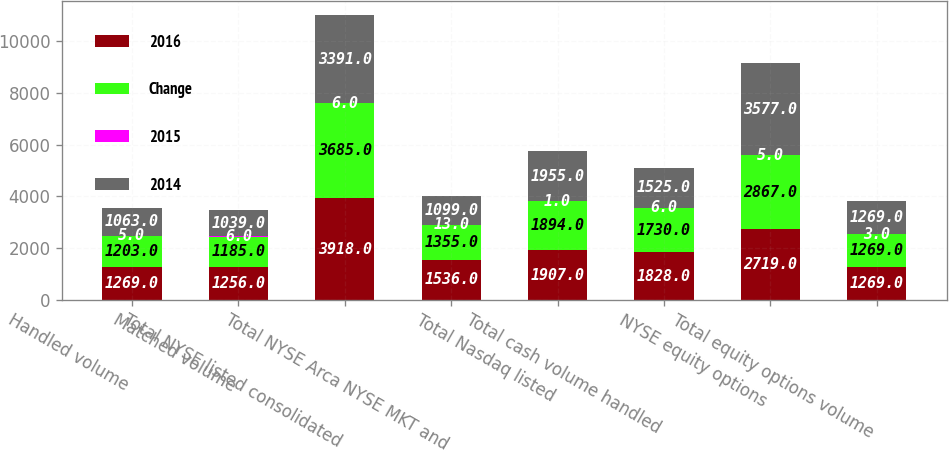<chart> <loc_0><loc_0><loc_500><loc_500><stacked_bar_chart><ecel><fcel>Handled volume<fcel>Matched volume<fcel>Total NYSE listed consolidated<fcel>Total NYSE Arca NYSE MKT and<fcel>Total Nasdaq listed<fcel>Total cash volume handled<fcel>NYSE equity options<fcel>Total equity options volume<nl><fcel>2016<fcel>1269<fcel>1256<fcel>3918<fcel>1536<fcel>1907<fcel>1828<fcel>2719<fcel>1269<nl><fcel>Change<fcel>1203<fcel>1185<fcel>3685<fcel>1355<fcel>1894<fcel>1730<fcel>2867<fcel>1269<nl><fcel>2015<fcel>5<fcel>6<fcel>6<fcel>13<fcel>1<fcel>6<fcel>5<fcel>3<nl><fcel>2014<fcel>1063<fcel>1039<fcel>3391<fcel>1099<fcel>1955<fcel>1525<fcel>3577<fcel>1269<nl></chart> 